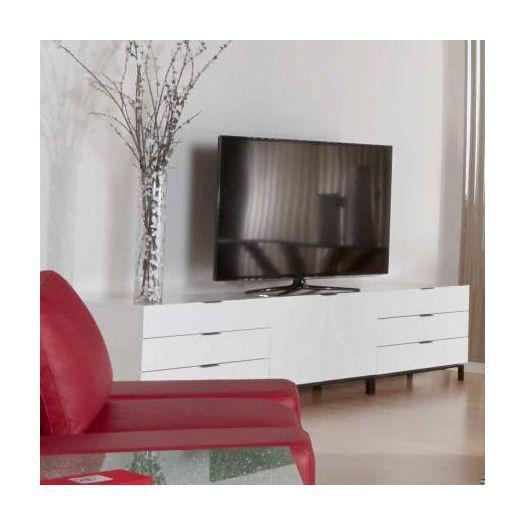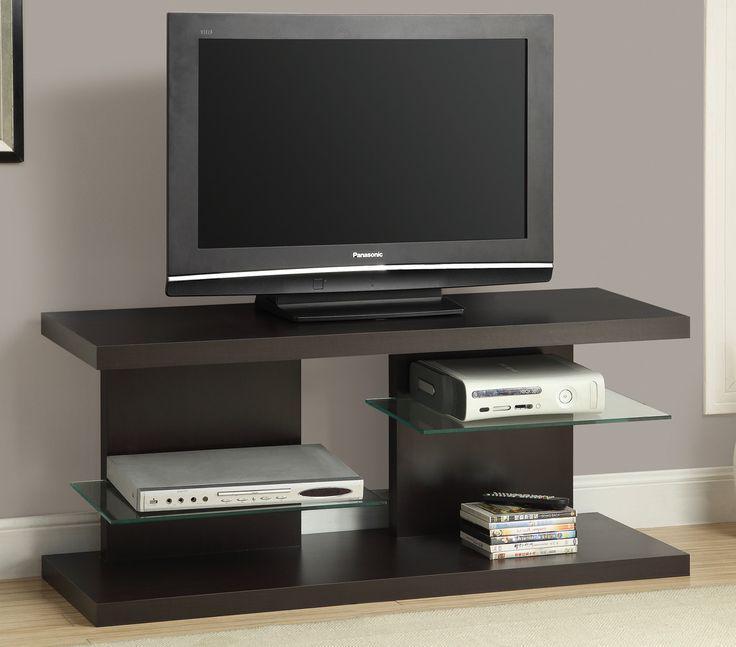The first image is the image on the left, the second image is the image on the right. For the images displayed, is the sentence "tv's are stacked in a triangular shape" factually correct? Answer yes or no. No. The first image is the image on the left, the second image is the image on the right. Evaluate the accuracy of this statement regarding the images: "Both images contain an equal number of monitors.". Is it true? Answer yes or no. Yes. 